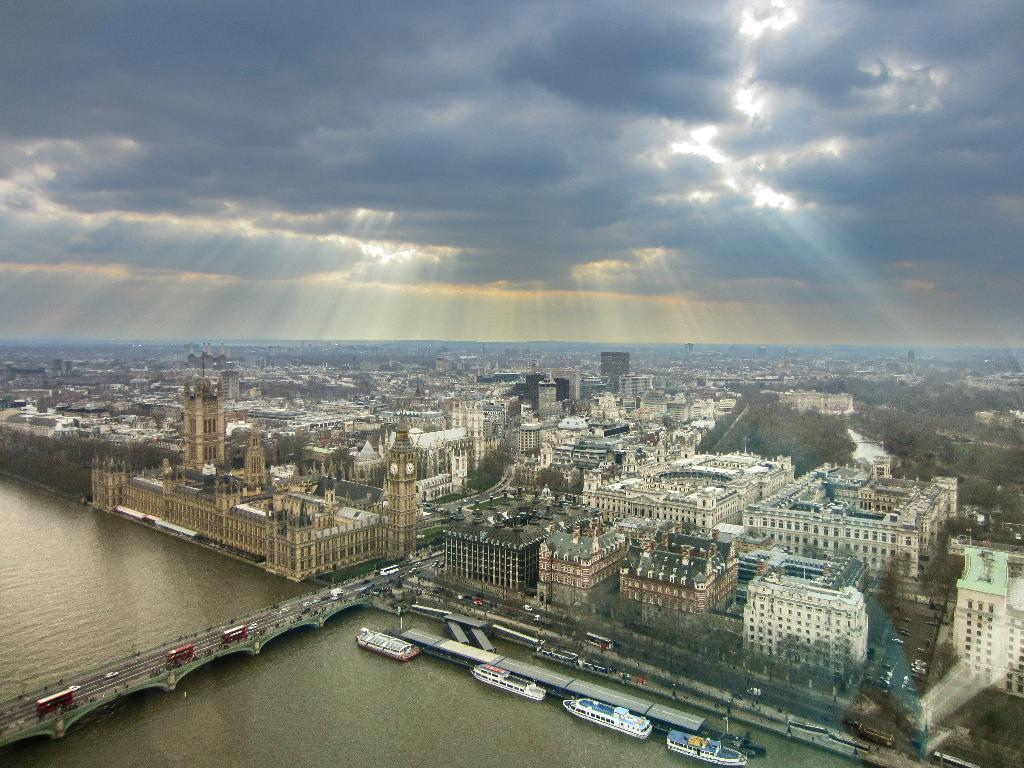What body of water is present in the image? There is a river in the image. How does the river connect different parts of the image? The river is connected by a bridge that goes over it. What else can be seen near the river? There are boats on the sides of the river. What type of structures are visible in the image? There are many buildings visible. What is visible in the sky in the image? The sky is visible with clouds. What type of health advice can be seen on the bridge in the image? There is no health advice present on the bridge in the image. 